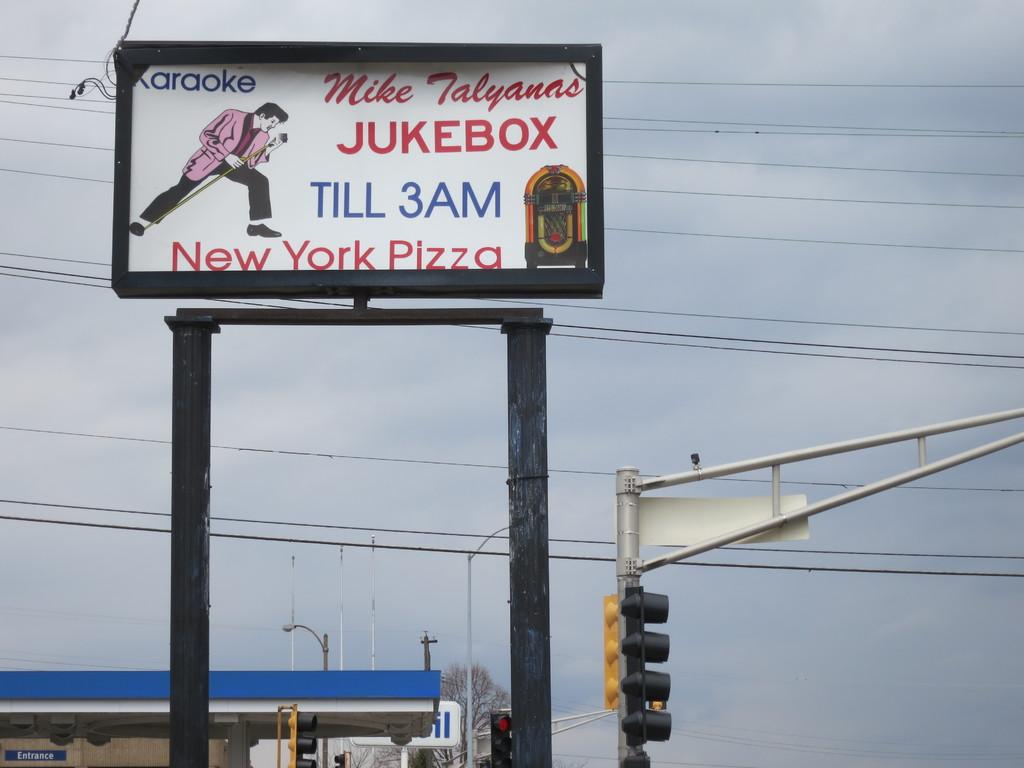<image>
Offer a succinct explanation of the picture presented. A billboard for the Mike Talyanas Jukebox offering Karaoke and New York Pizza. 